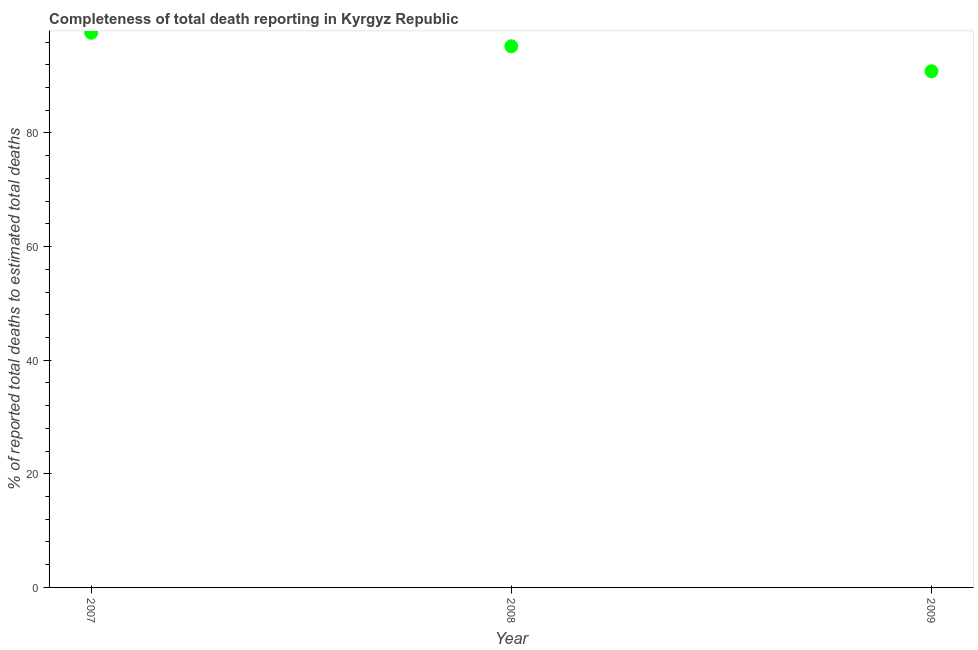What is the completeness of total death reports in 2009?
Provide a succinct answer. 90.87. Across all years, what is the maximum completeness of total death reports?
Keep it short and to the point. 97.65. Across all years, what is the minimum completeness of total death reports?
Offer a very short reply. 90.87. In which year was the completeness of total death reports minimum?
Your answer should be compact. 2009. What is the sum of the completeness of total death reports?
Your response must be concise. 283.79. What is the difference between the completeness of total death reports in 2007 and 2008?
Your response must be concise. 2.38. What is the average completeness of total death reports per year?
Your answer should be very brief. 94.6. What is the median completeness of total death reports?
Make the answer very short. 95.26. What is the ratio of the completeness of total death reports in 2007 to that in 2008?
Make the answer very short. 1.03. What is the difference between the highest and the second highest completeness of total death reports?
Keep it short and to the point. 2.38. Is the sum of the completeness of total death reports in 2008 and 2009 greater than the maximum completeness of total death reports across all years?
Offer a very short reply. Yes. What is the difference between the highest and the lowest completeness of total death reports?
Provide a short and direct response. 6.77. How many dotlines are there?
Make the answer very short. 1. How many years are there in the graph?
Keep it short and to the point. 3. What is the difference between two consecutive major ticks on the Y-axis?
Give a very brief answer. 20. Are the values on the major ticks of Y-axis written in scientific E-notation?
Offer a terse response. No. Does the graph contain any zero values?
Keep it short and to the point. No. What is the title of the graph?
Provide a short and direct response. Completeness of total death reporting in Kyrgyz Republic. What is the label or title of the X-axis?
Provide a short and direct response. Year. What is the label or title of the Y-axis?
Your answer should be very brief. % of reported total deaths to estimated total deaths. What is the % of reported total deaths to estimated total deaths in 2007?
Your answer should be compact. 97.65. What is the % of reported total deaths to estimated total deaths in 2008?
Ensure brevity in your answer.  95.26. What is the % of reported total deaths to estimated total deaths in 2009?
Provide a short and direct response. 90.87. What is the difference between the % of reported total deaths to estimated total deaths in 2007 and 2008?
Provide a short and direct response. 2.38. What is the difference between the % of reported total deaths to estimated total deaths in 2007 and 2009?
Give a very brief answer. 6.77. What is the difference between the % of reported total deaths to estimated total deaths in 2008 and 2009?
Provide a succinct answer. 4.39. What is the ratio of the % of reported total deaths to estimated total deaths in 2007 to that in 2009?
Your answer should be very brief. 1.07. What is the ratio of the % of reported total deaths to estimated total deaths in 2008 to that in 2009?
Your answer should be compact. 1.05. 